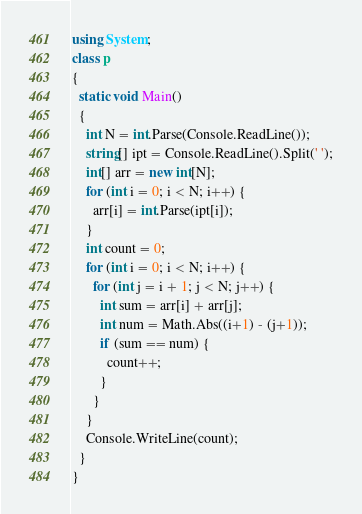Convert code to text. <code><loc_0><loc_0><loc_500><loc_500><_C#_>using System;
class p
{
  static void Main()
  {
    int N = int.Parse(Console.ReadLine());
    string[] ipt = Console.ReadLine().Split(' ');
    int[] arr = new int[N];
    for (int i = 0; i < N; i++) {
      arr[i] = int.Parse(ipt[i]);
    }
    int count = 0;
    for (int i = 0; i < N; i++) {
      for (int j = i + 1; j < N; j++) {
        int sum = arr[i] + arr[j];
        int num = Math.Abs((i+1) - (j+1));
        if (sum == num) {
          count++;
        }
      }
    }
    Console.WriteLine(count);
  }
}</code> 